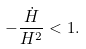Convert formula to latex. <formula><loc_0><loc_0><loc_500><loc_500>- \frac { \dot { H } } { H ^ { 2 } } < 1 .</formula> 